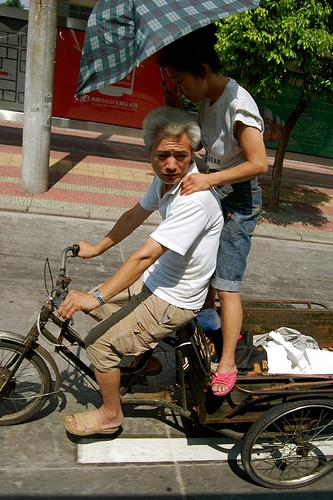Describe the objects in this image and their specific colors. I can see bicycle in darkgray, black, and gray tones, people in darkgray, lightgray, tan, gray, and maroon tones, people in darkgray, black, gray, tan, and maroon tones, and umbrella in darkgray, gray, black, and teal tones in this image. 